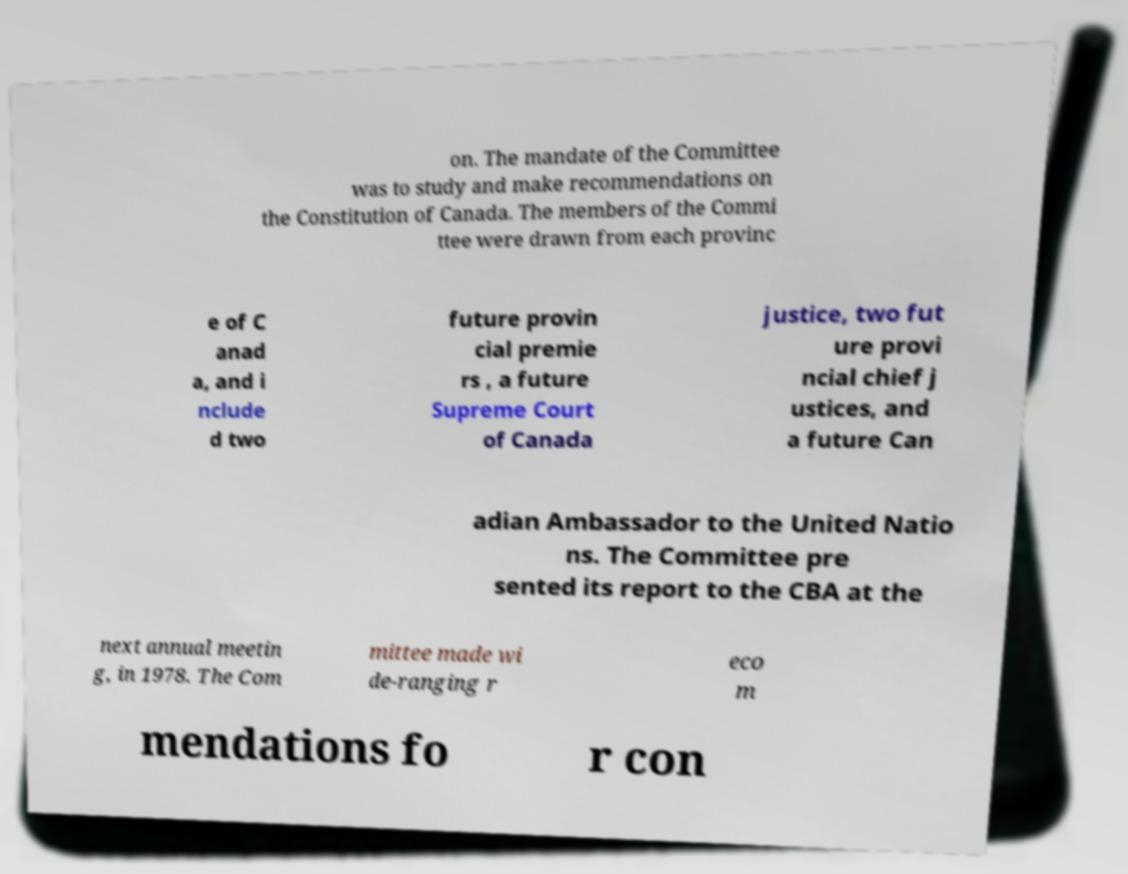Can you accurately transcribe the text from the provided image for me? on. The mandate of the Committee was to study and make recommendations on the Constitution of Canada. The members of the Commi ttee were drawn from each provinc e of C anad a, and i nclude d two future provin cial premie rs , a future Supreme Court of Canada justice, two fut ure provi ncial chief j ustices, and a future Can adian Ambassador to the United Natio ns. The Committee pre sented its report to the CBA at the next annual meetin g, in 1978. The Com mittee made wi de-ranging r eco m mendations fo r con 